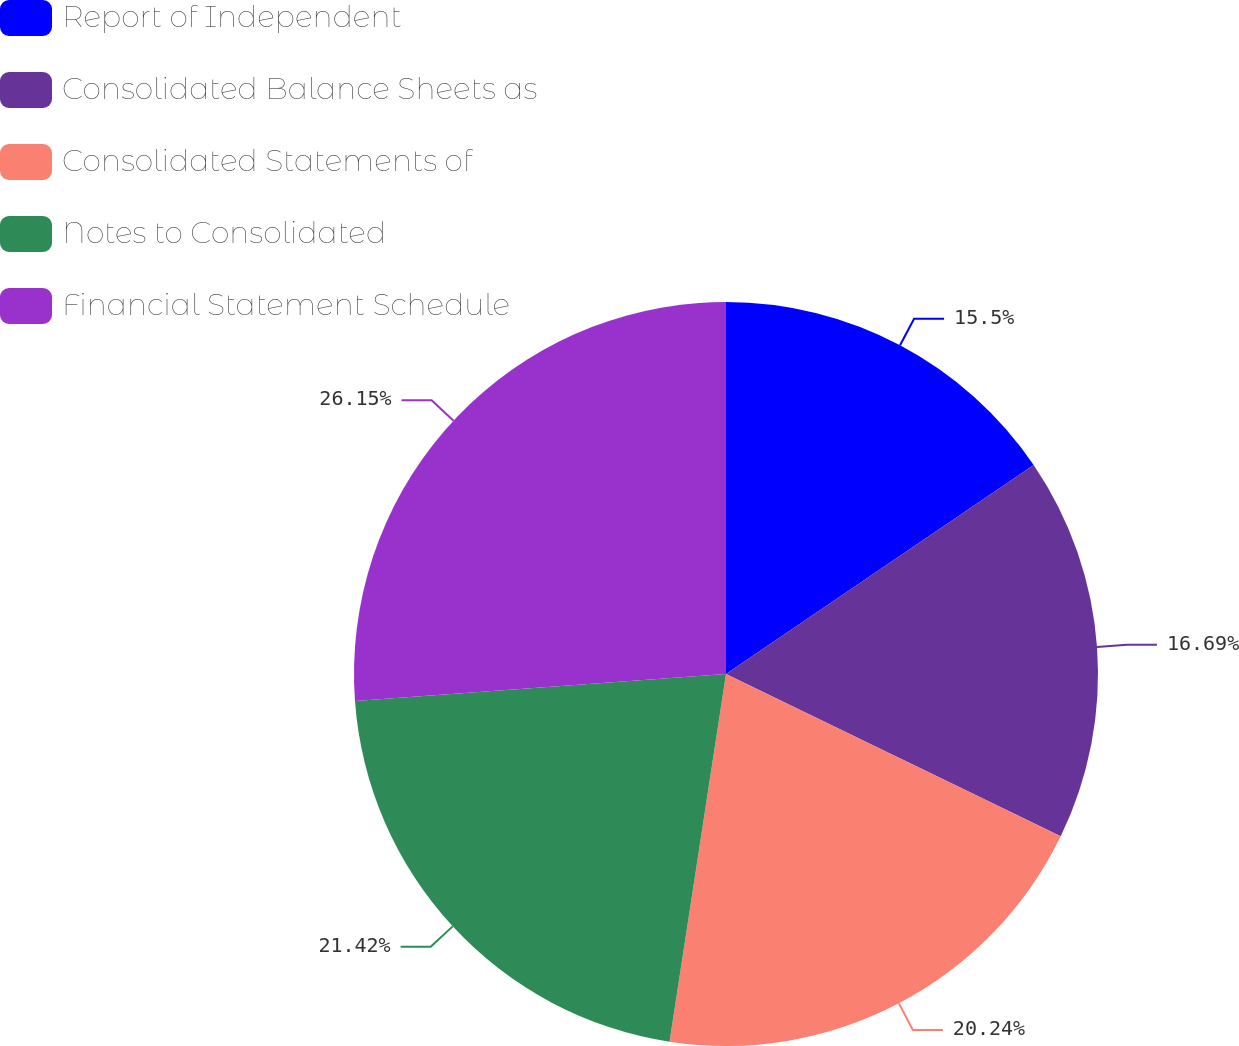<chart> <loc_0><loc_0><loc_500><loc_500><pie_chart><fcel>Report of Independent<fcel>Consolidated Balance Sheets as<fcel>Consolidated Statements of<fcel>Notes to Consolidated<fcel>Financial Statement Schedule<nl><fcel>15.5%<fcel>16.69%<fcel>20.24%<fcel>21.42%<fcel>26.16%<nl></chart> 